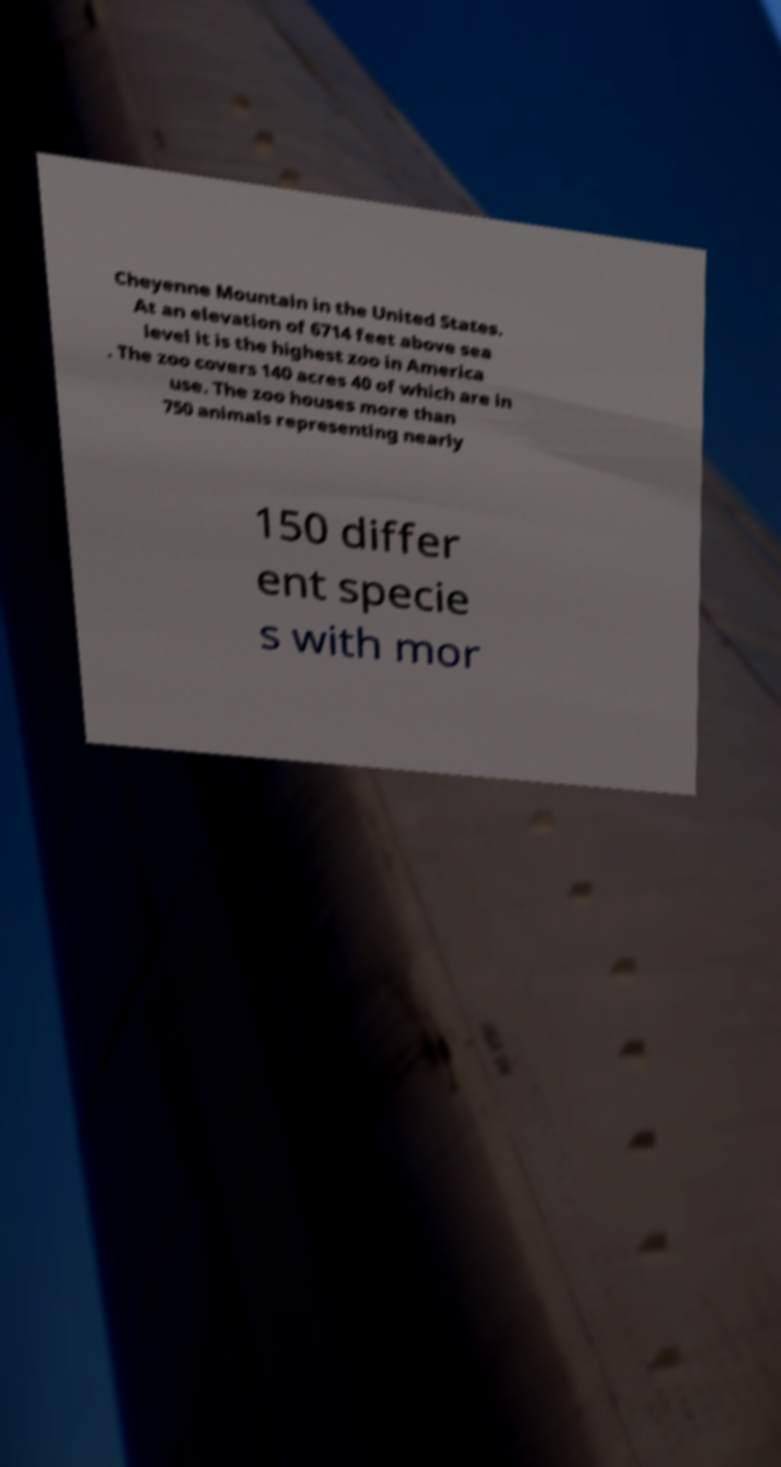Please identify and transcribe the text found in this image. Cheyenne Mountain in the United States. At an elevation of 6714 feet above sea level it is the highest zoo in America . The zoo covers 140 acres 40 of which are in use. The zoo houses more than 750 animals representing nearly 150 differ ent specie s with mor 